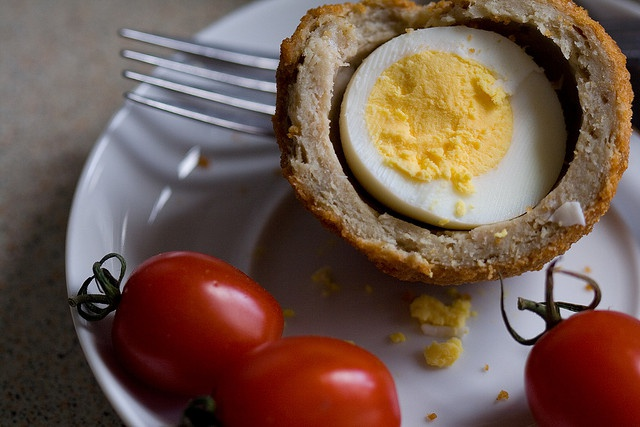Describe the objects in this image and their specific colors. I can see sandwich in gray, black, darkgray, and maroon tones, dining table in gray and black tones, and fork in gray, darkgray, and lavender tones in this image. 